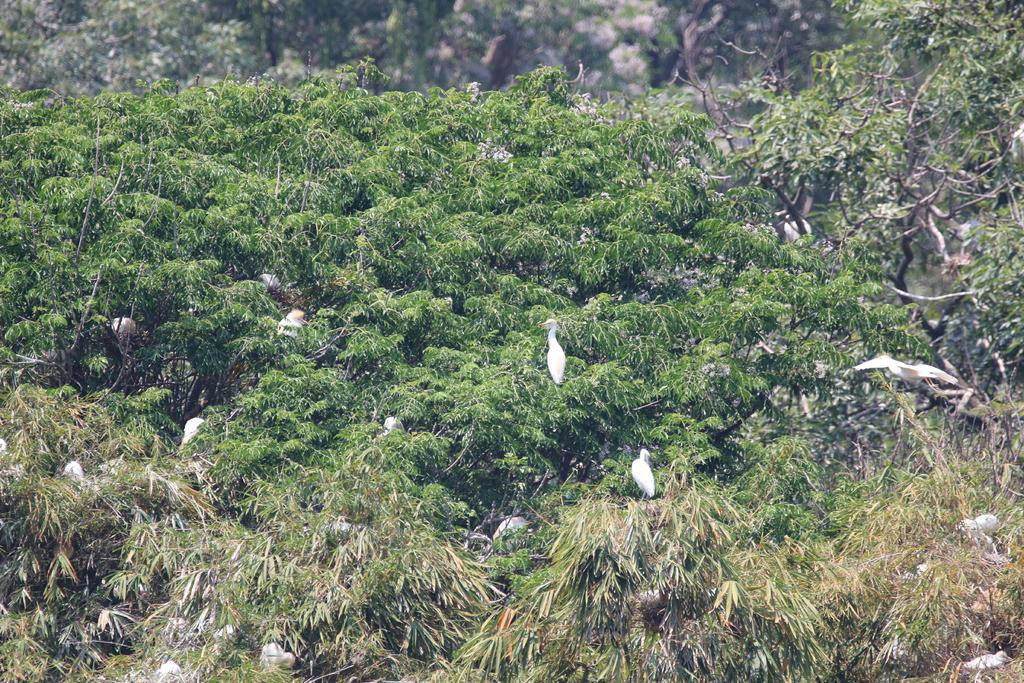What type of animals can be seen in the image? There are birds in the image. Where are the birds located? The birds are on branches. What can be seen in the background of the image? There are trees in the background of the image. What type of pet is sitting on the owner's lap in the image? There is no pet or owner present in the image; it features birds on branches with trees in the background. 